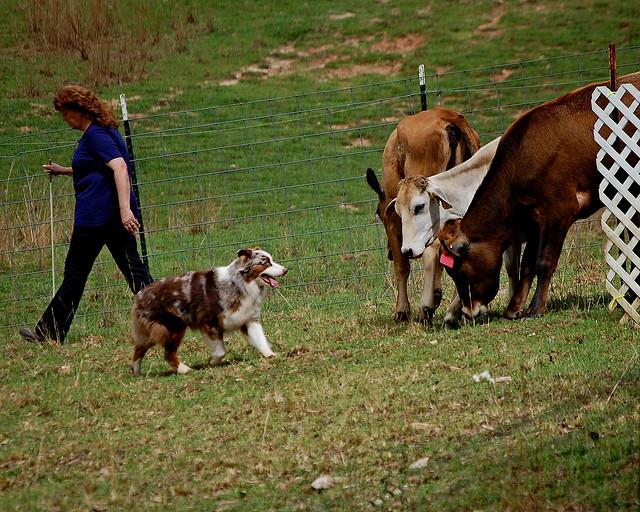What color is the fence?
Answer briefly. White. How many cows are standing in front of the dog?
Write a very short answer. 3. How many non-horse animals are in the picture?
Answer briefly. 4. Is this someone background?
Write a very short answer. Yes. What breed of dog is this?
Keep it brief. Collie. Which animal has a pink tag?
Keep it brief. Cow. 